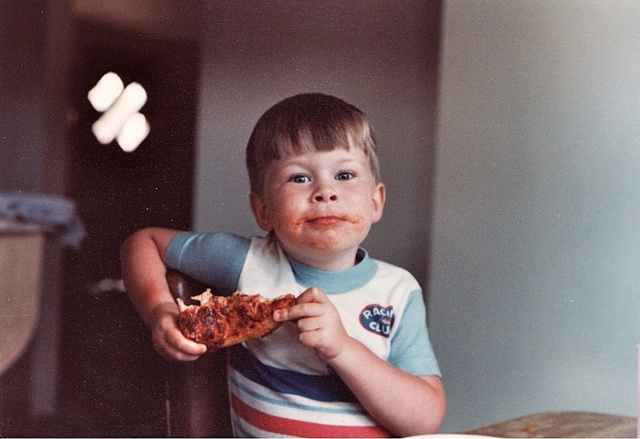Describe the objects in this image and their specific colors. I can see people in black, lightpink, maroon, and gray tones, chair in black, maroon, and brown tones, pizza in black, maroon, and brown tones, and dining table in black, gray, and darkgray tones in this image. 